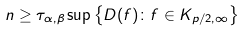Convert formula to latex. <formula><loc_0><loc_0><loc_500><loc_500>n \geq \tau _ { \alpha , \beta } \sup \left \{ D ( f ) \colon f \in K _ { p / 2 , \infty } \right \}</formula> 